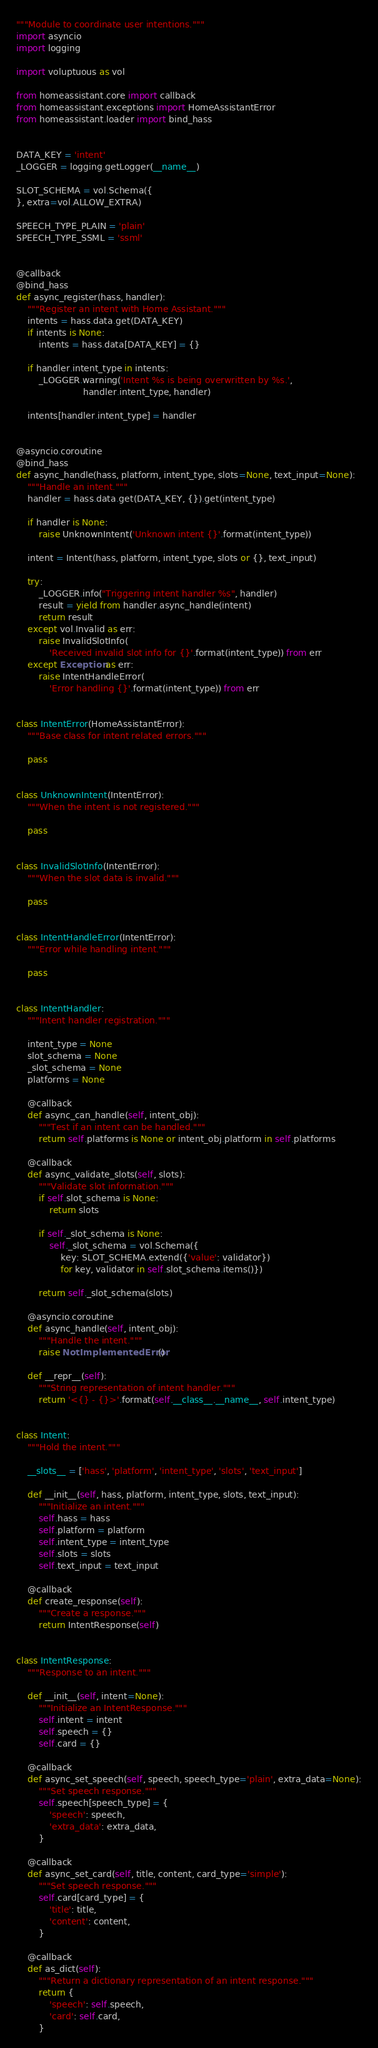Convert code to text. <code><loc_0><loc_0><loc_500><loc_500><_Python_>"""Module to coordinate user intentions."""
import asyncio
import logging

import voluptuous as vol

from homeassistant.core import callback
from homeassistant.exceptions import HomeAssistantError
from homeassistant.loader import bind_hass


DATA_KEY = 'intent'
_LOGGER = logging.getLogger(__name__)

SLOT_SCHEMA = vol.Schema({
}, extra=vol.ALLOW_EXTRA)

SPEECH_TYPE_PLAIN = 'plain'
SPEECH_TYPE_SSML = 'ssml'


@callback
@bind_hass
def async_register(hass, handler):
    """Register an intent with Home Assistant."""
    intents = hass.data.get(DATA_KEY)
    if intents is None:
        intents = hass.data[DATA_KEY] = {}

    if handler.intent_type in intents:
        _LOGGER.warning('Intent %s is being overwritten by %s.',
                        handler.intent_type, handler)

    intents[handler.intent_type] = handler


@asyncio.coroutine
@bind_hass
def async_handle(hass, platform, intent_type, slots=None, text_input=None):
    """Handle an intent."""
    handler = hass.data.get(DATA_KEY, {}).get(intent_type)

    if handler is None:
        raise UnknownIntent('Unknown intent {}'.format(intent_type))

    intent = Intent(hass, platform, intent_type, slots or {}, text_input)

    try:
        _LOGGER.info("Triggering intent handler %s", handler)
        result = yield from handler.async_handle(intent)
        return result
    except vol.Invalid as err:
        raise InvalidSlotInfo(
            'Received invalid slot info for {}'.format(intent_type)) from err
    except Exception as err:
        raise IntentHandleError(
            'Error handling {}'.format(intent_type)) from err


class IntentError(HomeAssistantError):
    """Base class for intent related errors."""

    pass


class UnknownIntent(IntentError):
    """When the intent is not registered."""

    pass


class InvalidSlotInfo(IntentError):
    """When the slot data is invalid."""

    pass


class IntentHandleError(IntentError):
    """Error while handling intent."""

    pass


class IntentHandler:
    """Intent handler registration."""

    intent_type = None
    slot_schema = None
    _slot_schema = None
    platforms = None

    @callback
    def async_can_handle(self, intent_obj):
        """Test if an intent can be handled."""
        return self.platforms is None or intent_obj.platform in self.platforms

    @callback
    def async_validate_slots(self, slots):
        """Validate slot information."""
        if self.slot_schema is None:
            return slots

        if self._slot_schema is None:
            self._slot_schema = vol.Schema({
                key: SLOT_SCHEMA.extend({'value': validator})
                for key, validator in self.slot_schema.items()})

        return self._slot_schema(slots)

    @asyncio.coroutine
    def async_handle(self, intent_obj):
        """Handle the intent."""
        raise NotImplementedError()

    def __repr__(self):
        """String representation of intent handler."""
        return '<{} - {}>'.format(self.__class__.__name__, self.intent_type)


class Intent:
    """Hold the intent."""

    __slots__ = ['hass', 'platform', 'intent_type', 'slots', 'text_input']

    def __init__(self, hass, platform, intent_type, slots, text_input):
        """Initialize an intent."""
        self.hass = hass
        self.platform = platform
        self.intent_type = intent_type
        self.slots = slots
        self.text_input = text_input

    @callback
    def create_response(self):
        """Create a response."""
        return IntentResponse(self)


class IntentResponse:
    """Response to an intent."""

    def __init__(self, intent=None):
        """Initialize an IntentResponse."""
        self.intent = intent
        self.speech = {}
        self.card = {}

    @callback
    def async_set_speech(self, speech, speech_type='plain', extra_data=None):
        """Set speech response."""
        self.speech[speech_type] = {
            'speech': speech,
            'extra_data': extra_data,
        }

    @callback
    def async_set_card(self, title, content, card_type='simple'):
        """Set speech response."""
        self.card[card_type] = {
            'title': title,
            'content': content,
        }

    @callback
    def as_dict(self):
        """Return a dictionary representation of an intent response."""
        return {
            'speech': self.speech,
            'card': self.card,
        }
</code> 